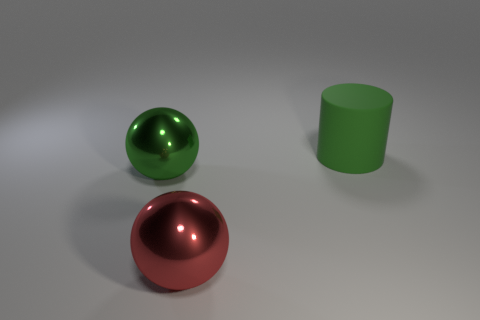Is the material of the big ball behind the red shiny thing the same as the green object right of the large red metallic ball?
Provide a short and direct response. No. How many cylinders are either large green rubber things or small cyan objects?
Make the answer very short. 1. How many shiny things are in front of the big green object behind the large green object on the left side of the big red thing?
Your response must be concise. 2. There is a large red thing that is the same shape as the large green shiny thing; what is it made of?
Ensure brevity in your answer.  Metal. Are there any other things that have the same material as the red ball?
Your response must be concise. Yes. The big metallic object that is left of the red shiny thing is what color?
Offer a terse response. Green. Do the cylinder and the green object on the left side of the green matte object have the same material?
Make the answer very short. No. What is the big red thing made of?
Your answer should be very brief. Metal. There is a green object that is made of the same material as the red ball; what shape is it?
Ensure brevity in your answer.  Sphere. What number of other objects are there of the same shape as the green matte object?
Your answer should be very brief. 0. 